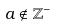Convert formula to latex. <formula><loc_0><loc_0><loc_500><loc_500>a \notin \mathbb { Z } ^ { - }</formula> 